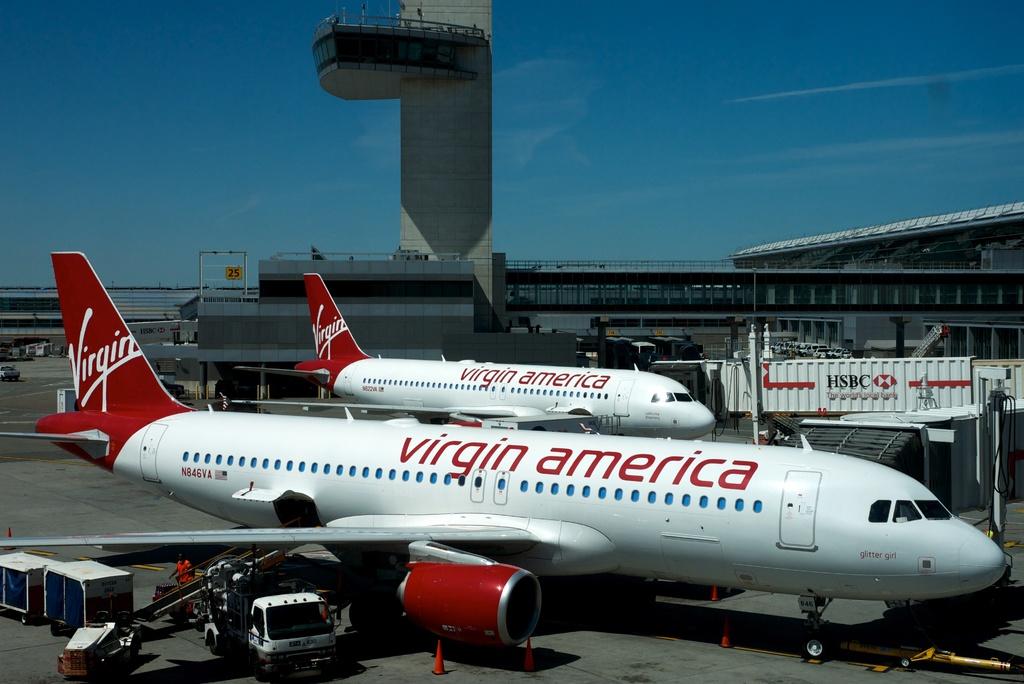What airline is that?
Offer a terse response. Virgin america. Whats the name of the airline?
Give a very brief answer. Virgin america. 